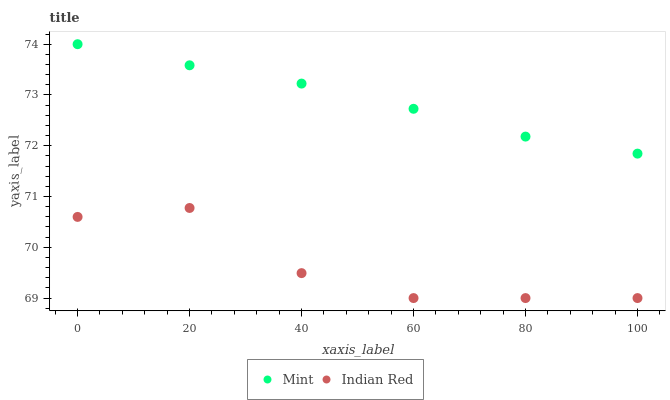Does Indian Red have the minimum area under the curve?
Answer yes or no. Yes. Does Mint have the maximum area under the curve?
Answer yes or no. Yes. Does Indian Red have the maximum area under the curve?
Answer yes or no. No. Is Mint the smoothest?
Answer yes or no. Yes. Is Indian Red the roughest?
Answer yes or no. Yes. Is Indian Red the smoothest?
Answer yes or no. No. Does Indian Red have the lowest value?
Answer yes or no. Yes. Does Mint have the highest value?
Answer yes or no. Yes. Does Indian Red have the highest value?
Answer yes or no. No. Is Indian Red less than Mint?
Answer yes or no. Yes. Is Mint greater than Indian Red?
Answer yes or no. Yes. Does Indian Red intersect Mint?
Answer yes or no. No. 